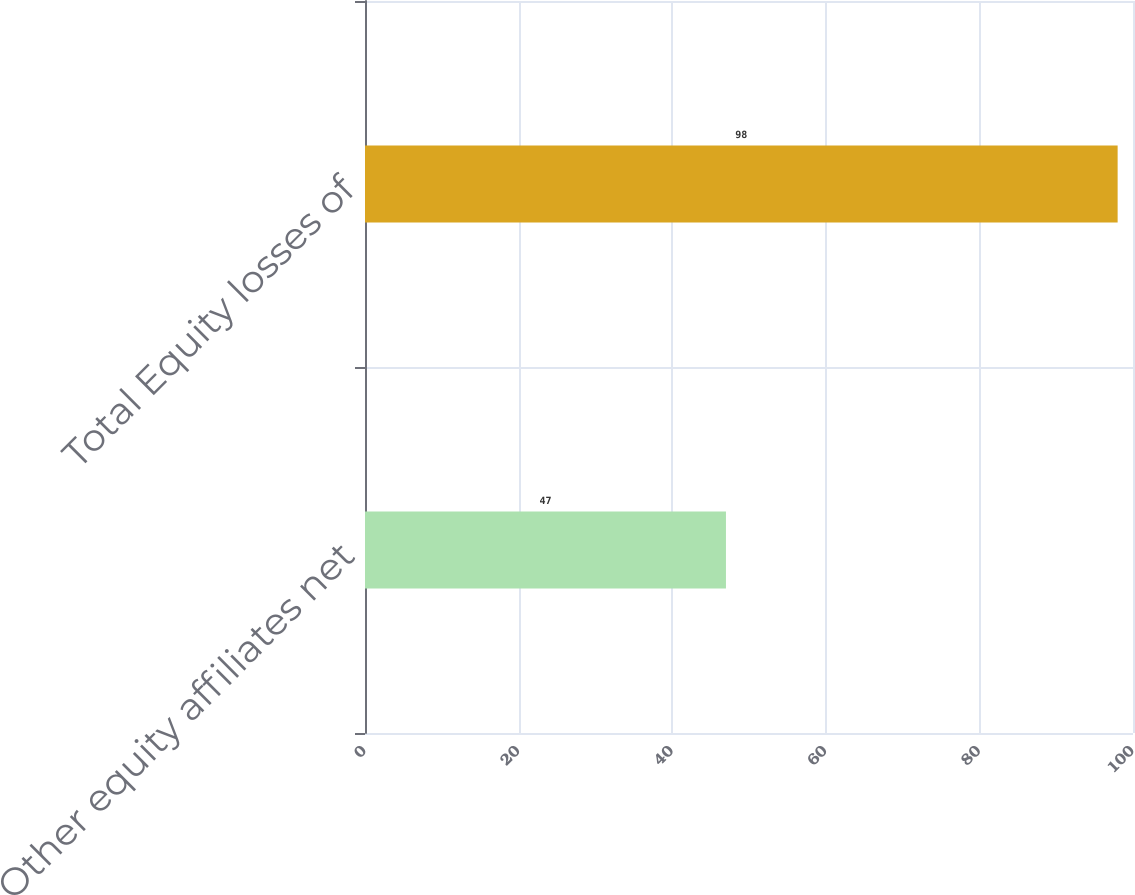Convert chart. <chart><loc_0><loc_0><loc_500><loc_500><bar_chart><fcel>Other equity affiliates net<fcel>Total Equity losses of<nl><fcel>47<fcel>98<nl></chart> 